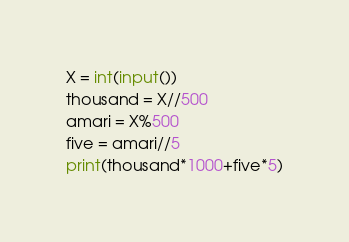Convert code to text. <code><loc_0><loc_0><loc_500><loc_500><_Python_>X = int(input())
thousand = X//500
amari = X%500
five = amari//5
print(thousand*1000+five*5)</code> 